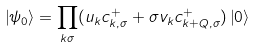Convert formula to latex. <formula><loc_0><loc_0><loc_500><loc_500>\left | \psi _ { 0 } \right \rangle = \underset { k \sigma } { \prod } ( u _ { k } c _ { k , \sigma } ^ { + } + \sigma v _ { k } c _ { k + Q , \sigma } ^ { + } ) \left | 0 \right \rangle</formula> 